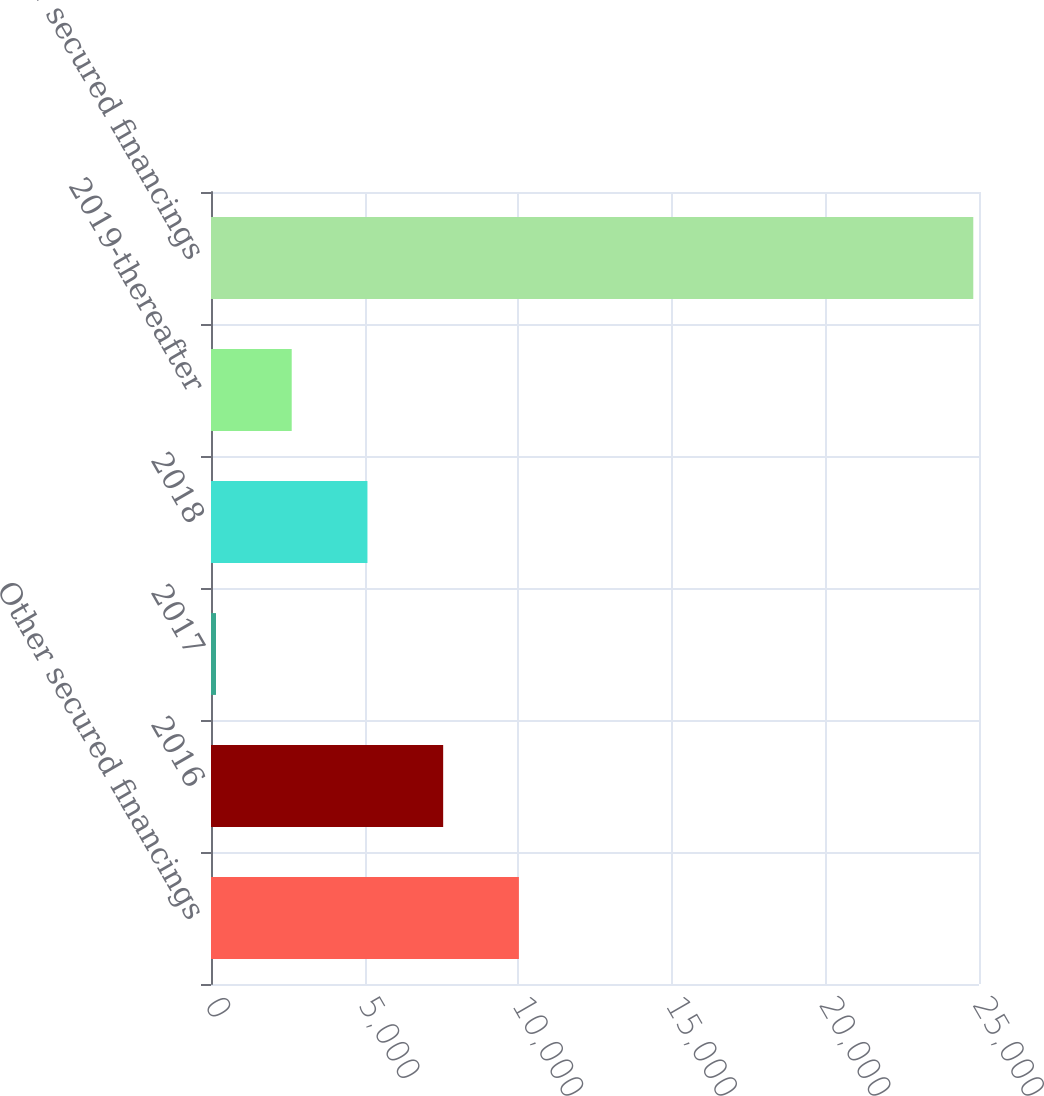Convert chart to OTSL. <chart><loc_0><loc_0><loc_500><loc_500><bar_chart><fcel>Other secured financings<fcel>2016<fcel>2017<fcel>2018<fcel>2019-thereafter<fcel>Total other secured financings<nl><fcel>10022.8<fcel>7557.6<fcel>162<fcel>5092.4<fcel>2627.2<fcel>24814<nl></chart> 